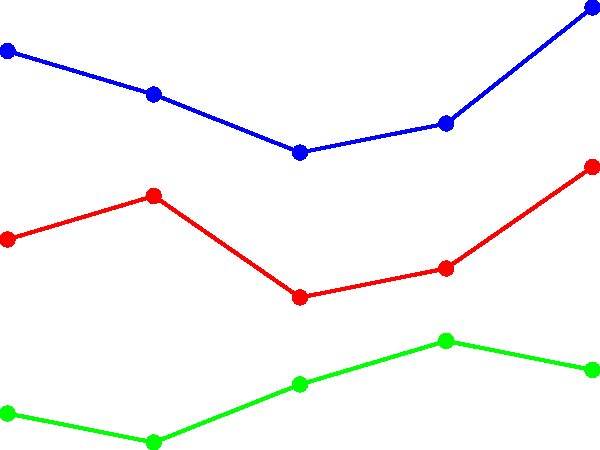Based on the line graph showing public opinion trends on key issues in Israel from 2018 to 2022, which issue consistently received the highest level of public support throughout the period, and how did its support change between 2020 and 2022? To answer this question, we need to analyze the line graph step-by-step:

1. Identify the three issues represented:
   - Blue line: Security
   - Red line: Economy
   - Green line: Peace Process

2. Observe that the blue line (Security) is consistently above the other two lines throughout the entire period from 2018 to 2022.

3. Focus on the Security line between 2020 and 2022:
   - In 2020, the support for Security was at 58%
   - In 2021, it increased to 60%
   - In 2022, it further increased to 68%

4. Calculate the total change in support from 2020 to 2022:
   68% - 58% = 10% increase

Therefore, Security consistently received the highest level of public support, and its support increased by 10 percentage points between 2020 and 2022.
Answer: Security; increased by 10 percentage points 